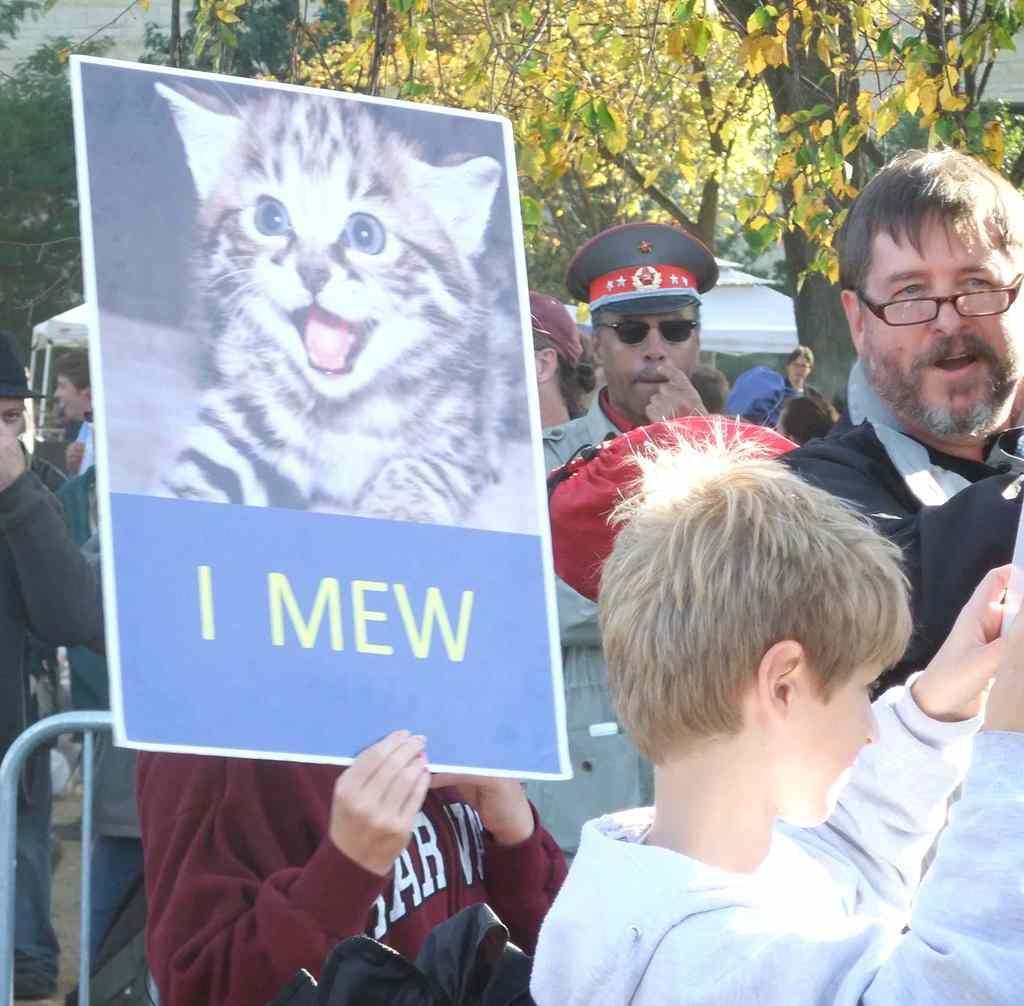In one or two sentences, can you explain what this image depicts? There are people and this person holding a poster and we can see rod and bag. In the background we can see trees and tent. 